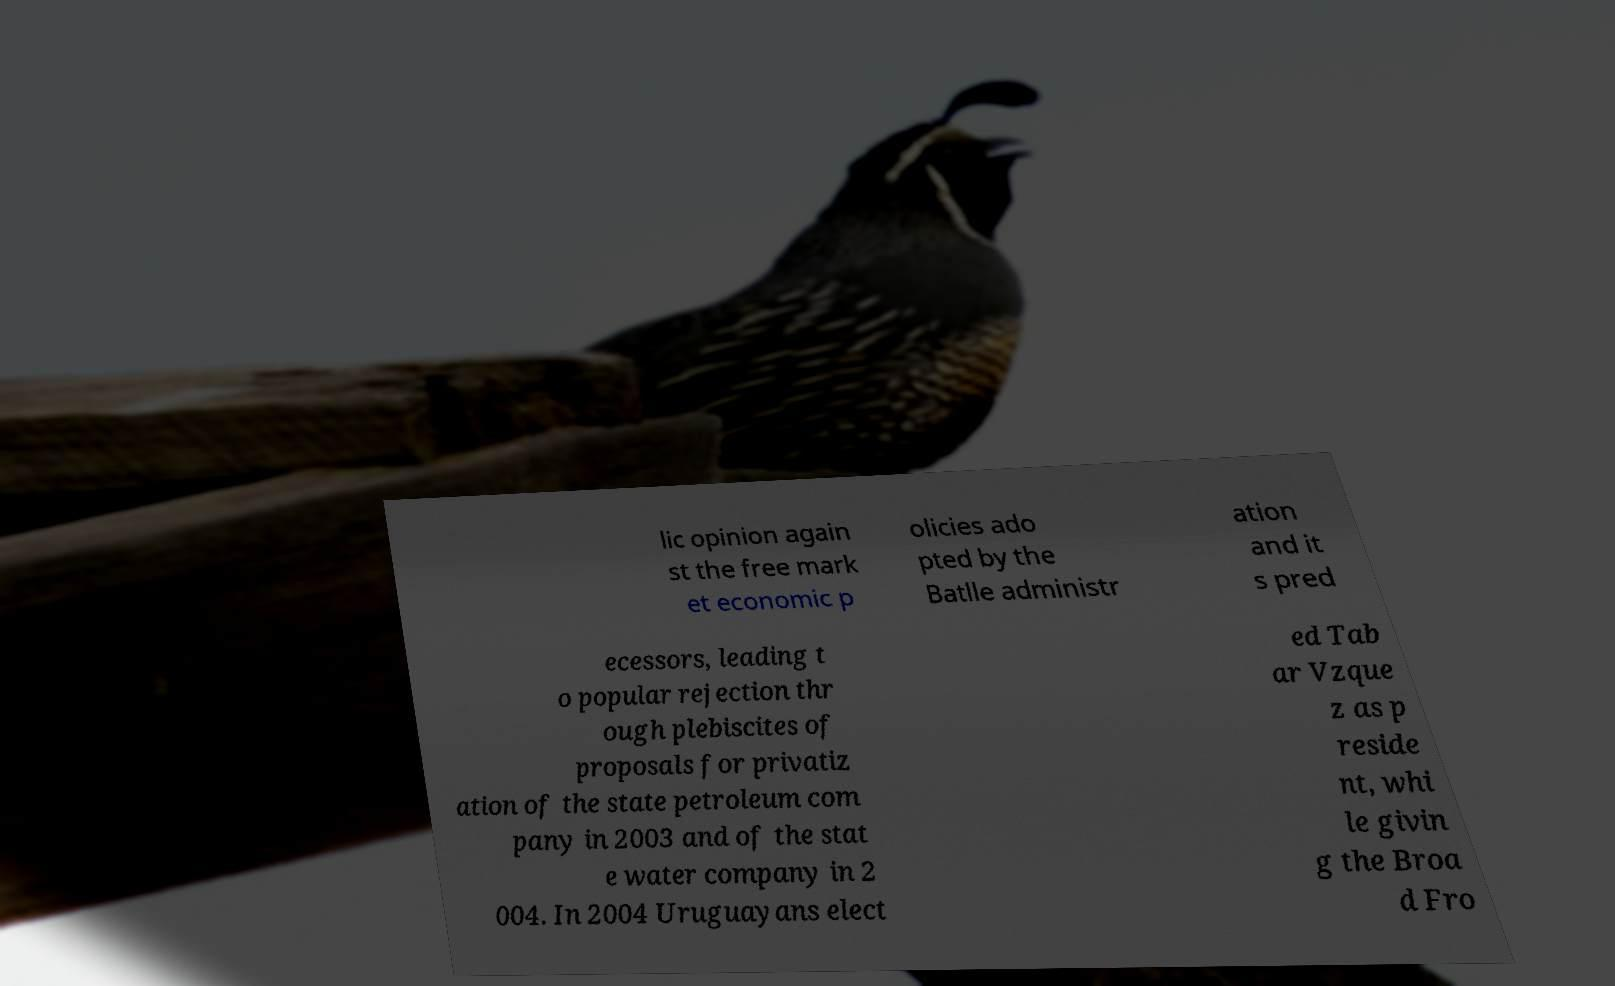Please read and relay the text visible in this image. What does it say? lic opinion again st the free mark et economic p olicies ado pted by the Batlle administr ation and it s pred ecessors, leading t o popular rejection thr ough plebiscites of proposals for privatiz ation of the state petroleum com pany in 2003 and of the stat e water company in 2 004. In 2004 Uruguayans elect ed Tab ar Vzque z as p reside nt, whi le givin g the Broa d Fro 